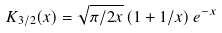Convert formula to latex. <formula><loc_0><loc_0><loc_500><loc_500>K _ { 3 / 2 } ( x ) = \sqrt { \pi / 2 x } \left ( 1 + 1 / x \right ) e ^ { - x }</formula> 